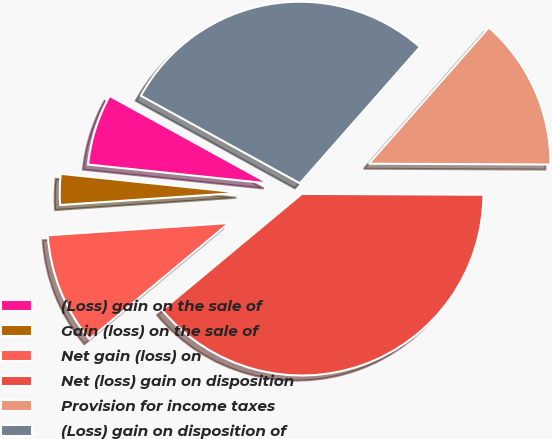<chart> <loc_0><loc_0><loc_500><loc_500><pie_chart><fcel>(Loss) gain on the sale of<fcel>Gain (loss) on the sale of<fcel>Net gain (loss) on<fcel>Net (loss) gain on disposition<fcel>Provision for income taxes<fcel>(Loss) gain on disposition of<nl><fcel>6.35%<fcel>2.74%<fcel>9.97%<fcel>38.88%<fcel>13.58%<fcel>28.48%<nl></chart> 